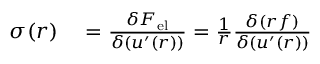<formula> <loc_0><loc_0><loc_500><loc_500>\begin{array} { r l } { \sigma ( r ) } & = \frac { \delta { F } _ { e l } } { \delta ( u ^ { \prime } ( r ) ) } = \frac { 1 } { r } \frac { \delta ( r f ) } { \delta ( u ^ { \prime } ( r ) ) } } \end{array}</formula> 